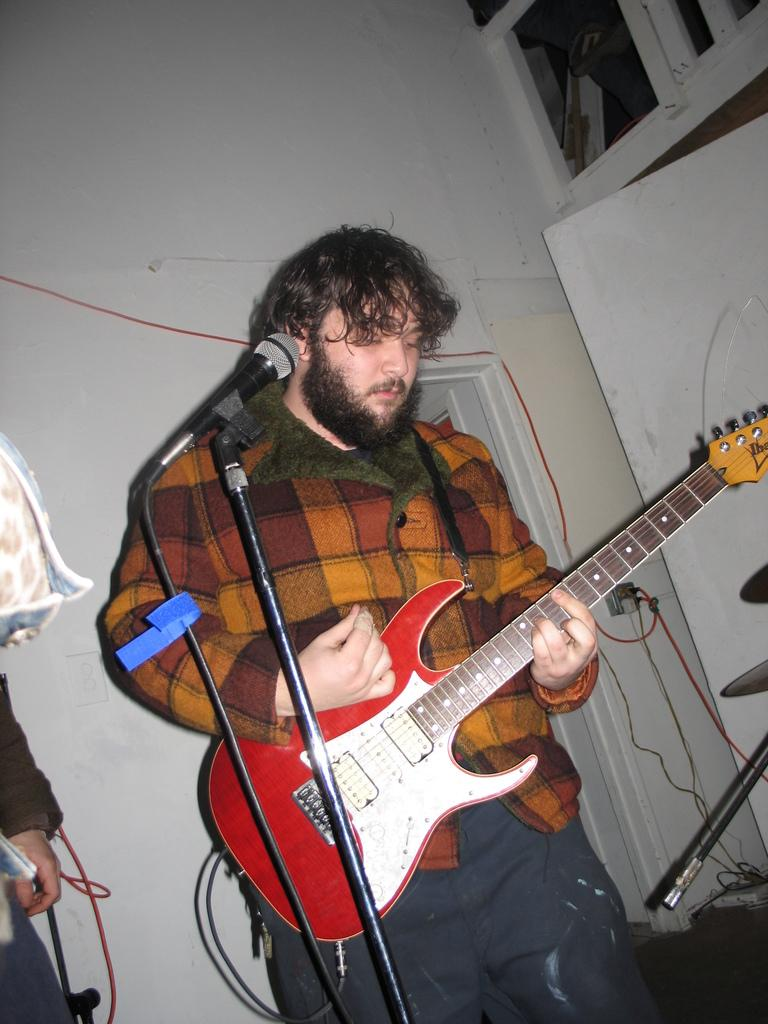What is the color of the wall in the image? The wall in the image is white. What is the man in the image holding? The man is holding a guitar in the image. What other object related to music can be seen in the image? There is a microphone (mic) in the image. How many trees can be seen in the image? There are no trees present in the image. What type of acoustics can be heard in the image? The image does not provide any information about the acoustics, as it is a still image and does not include any sound. 